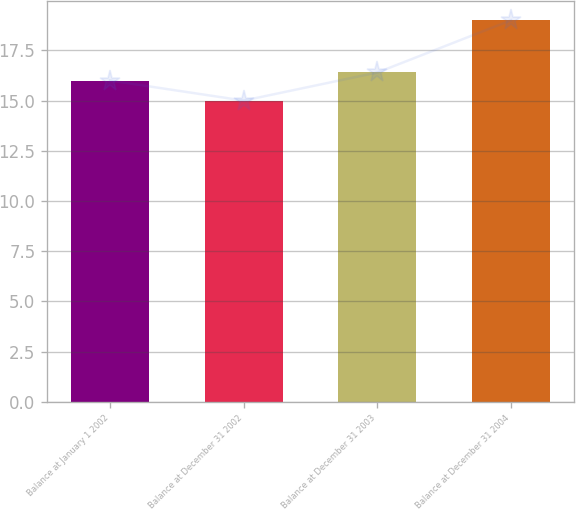Convert chart to OTSL. <chart><loc_0><loc_0><loc_500><loc_500><bar_chart><fcel>Balance at January 1 2002<fcel>Balance at December 31 2002<fcel>Balance at December 31 2003<fcel>Balance at December 31 2004<nl><fcel>16<fcel>15<fcel>16.4<fcel>19<nl></chart> 